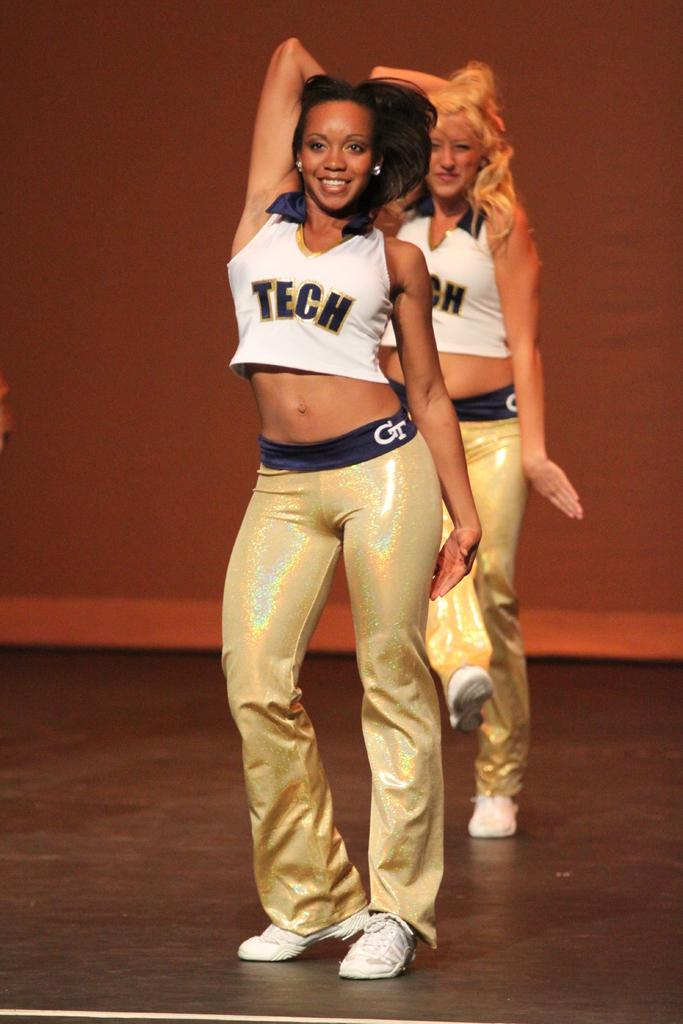<image>
Present a compact description of the photo's key features. girls dancing together on stage shirt reads tech 